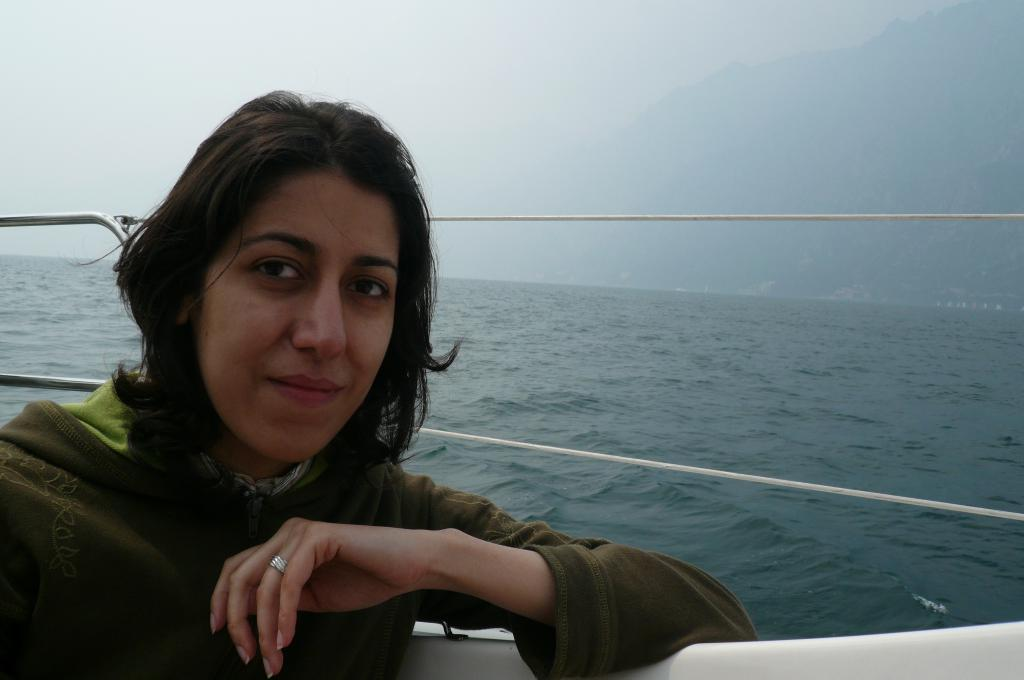Who or what is present in the image? There is a person in the image. What natural feature can be seen in the background? There is an ocean in the image. What type of landform is visible in the image? There are hills in the image. What part of the environment is visible above the land and ocean? The sky is visible in the image. What is the temper of the donkey in the image? There is no donkey present in the image. 